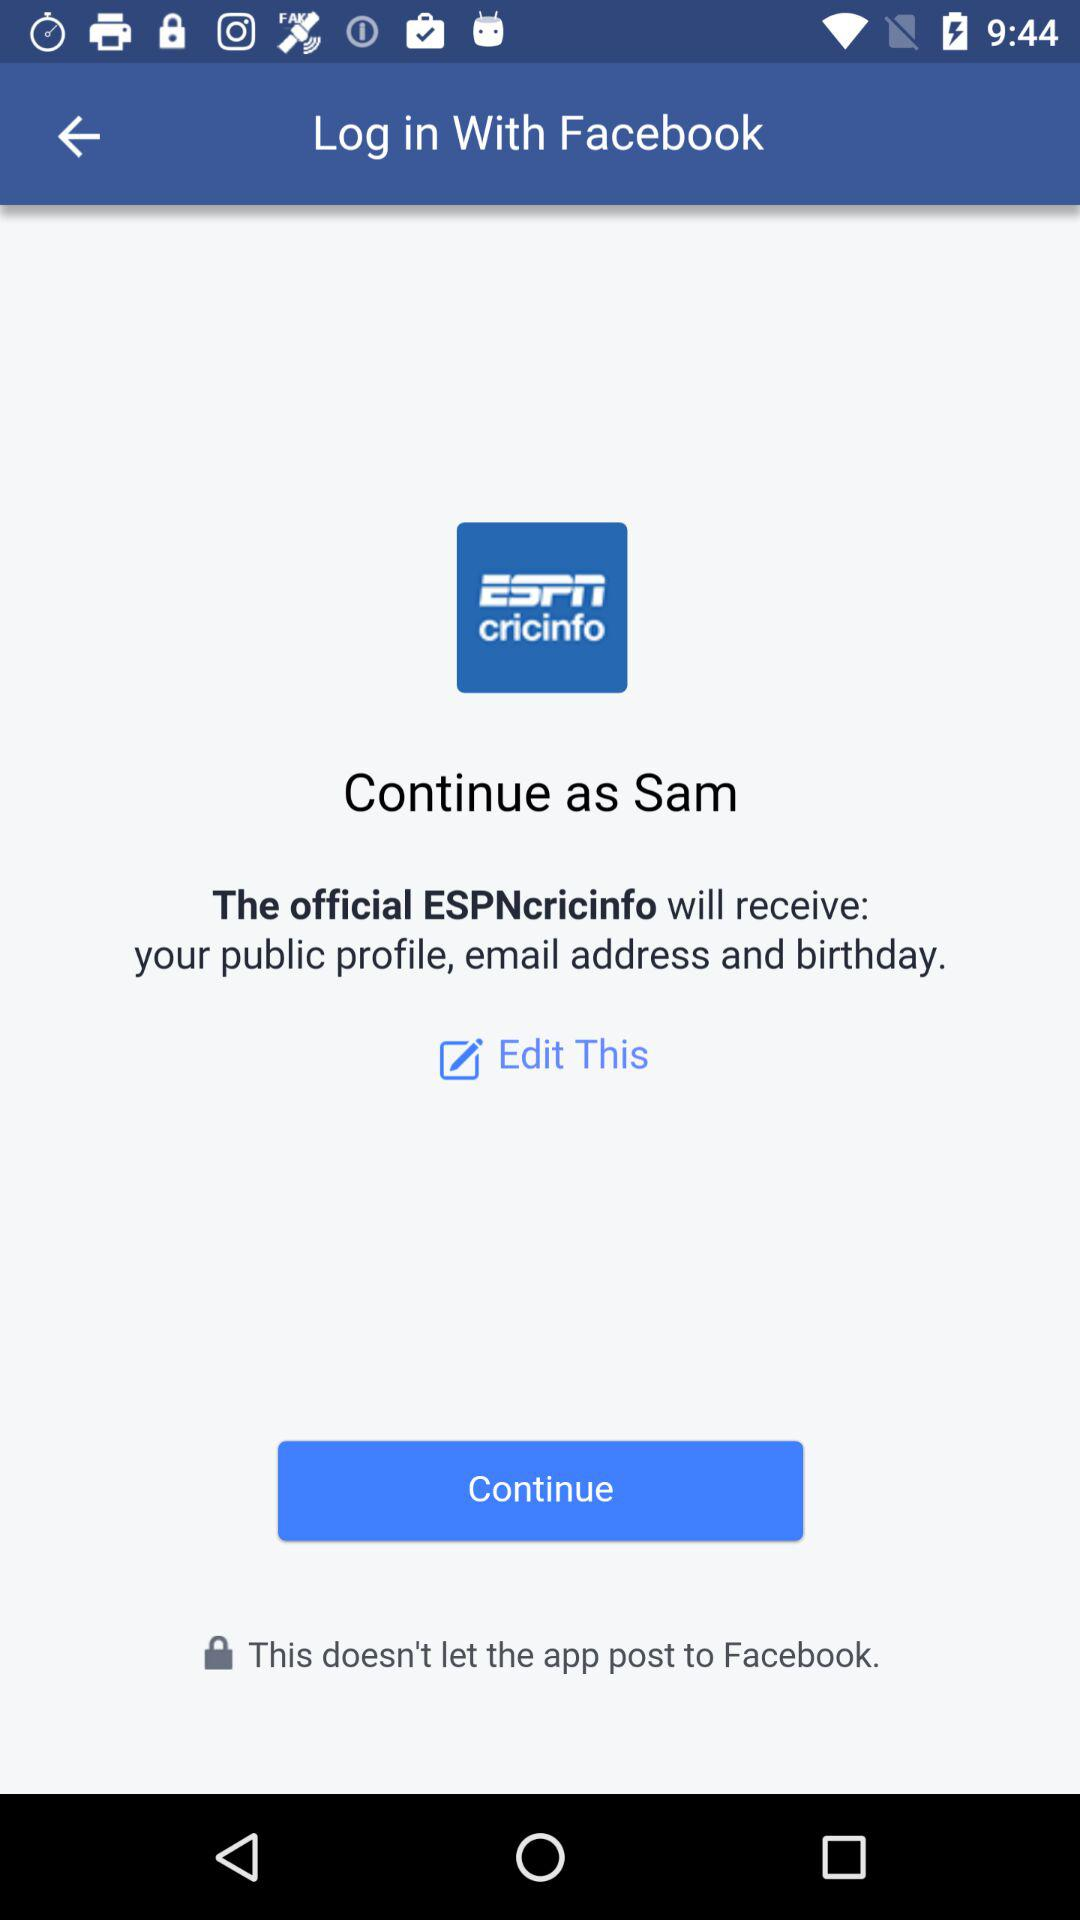Through what application can we log in? You can log in through "Facebook". 